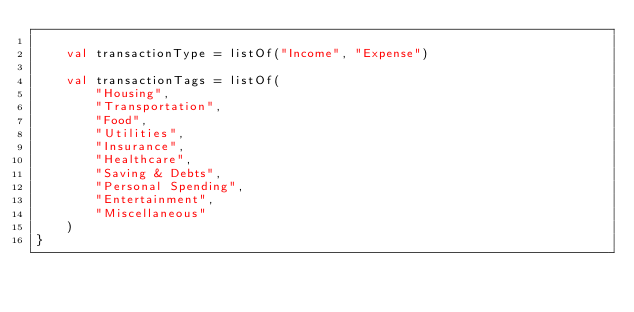Convert code to text. <code><loc_0><loc_0><loc_500><loc_500><_Kotlin_>
    val transactionType = listOf("Income", "Expense")

    val transactionTags = listOf(
        "Housing",
        "Transportation",
        "Food",
        "Utilities",
        "Insurance",
        "Healthcare",
        "Saving & Debts",
        "Personal Spending",
        "Entertainment",
        "Miscellaneous"
    )
}
</code> 